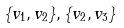Convert formula to latex. <formula><loc_0><loc_0><loc_500><loc_500>\{ v _ { 1 } , v _ { 2 } \} , \{ v _ { 2 } , v _ { 3 } \}</formula> 